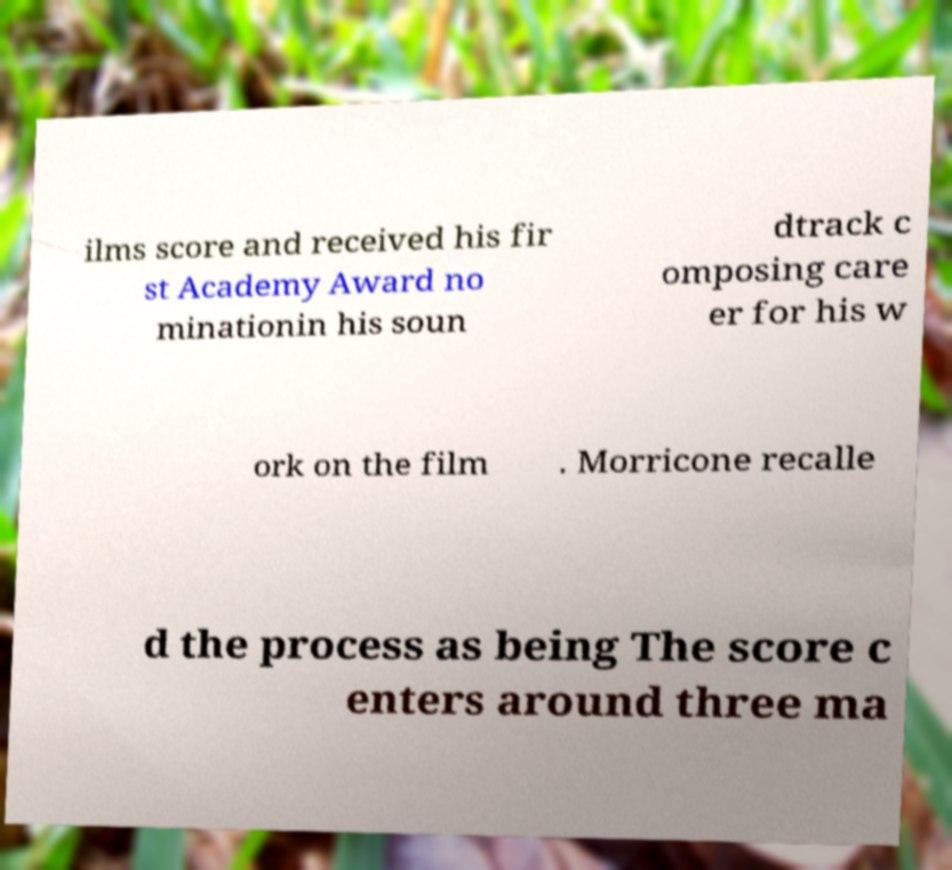For documentation purposes, I need the text within this image transcribed. Could you provide that? ilms score and received his fir st Academy Award no minationin his soun dtrack c omposing care er for his w ork on the film . Morricone recalle d the process as being The score c enters around three ma 